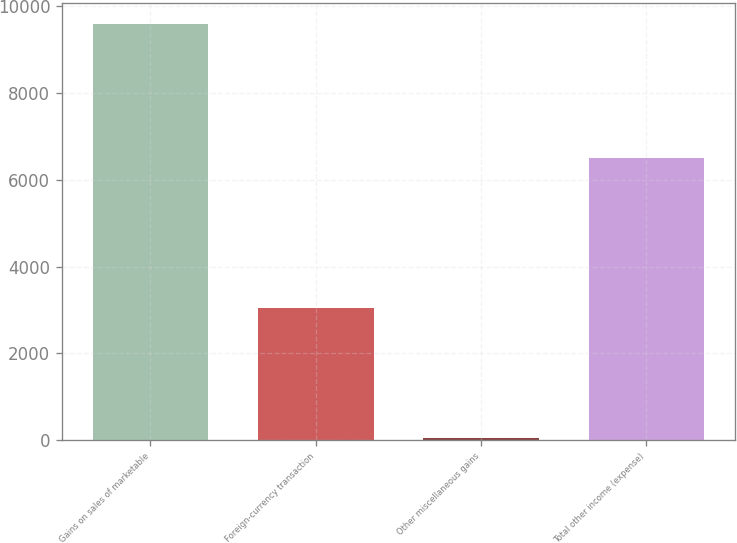Convert chart to OTSL. <chart><loc_0><loc_0><loc_500><loc_500><bar_chart><fcel>Gains on sales of marketable<fcel>Foreign-currency transaction<fcel>Other miscellaneous gains<fcel>Total other income (expense)<nl><fcel>9598<fcel>3043<fcel>41<fcel>6514<nl></chart> 